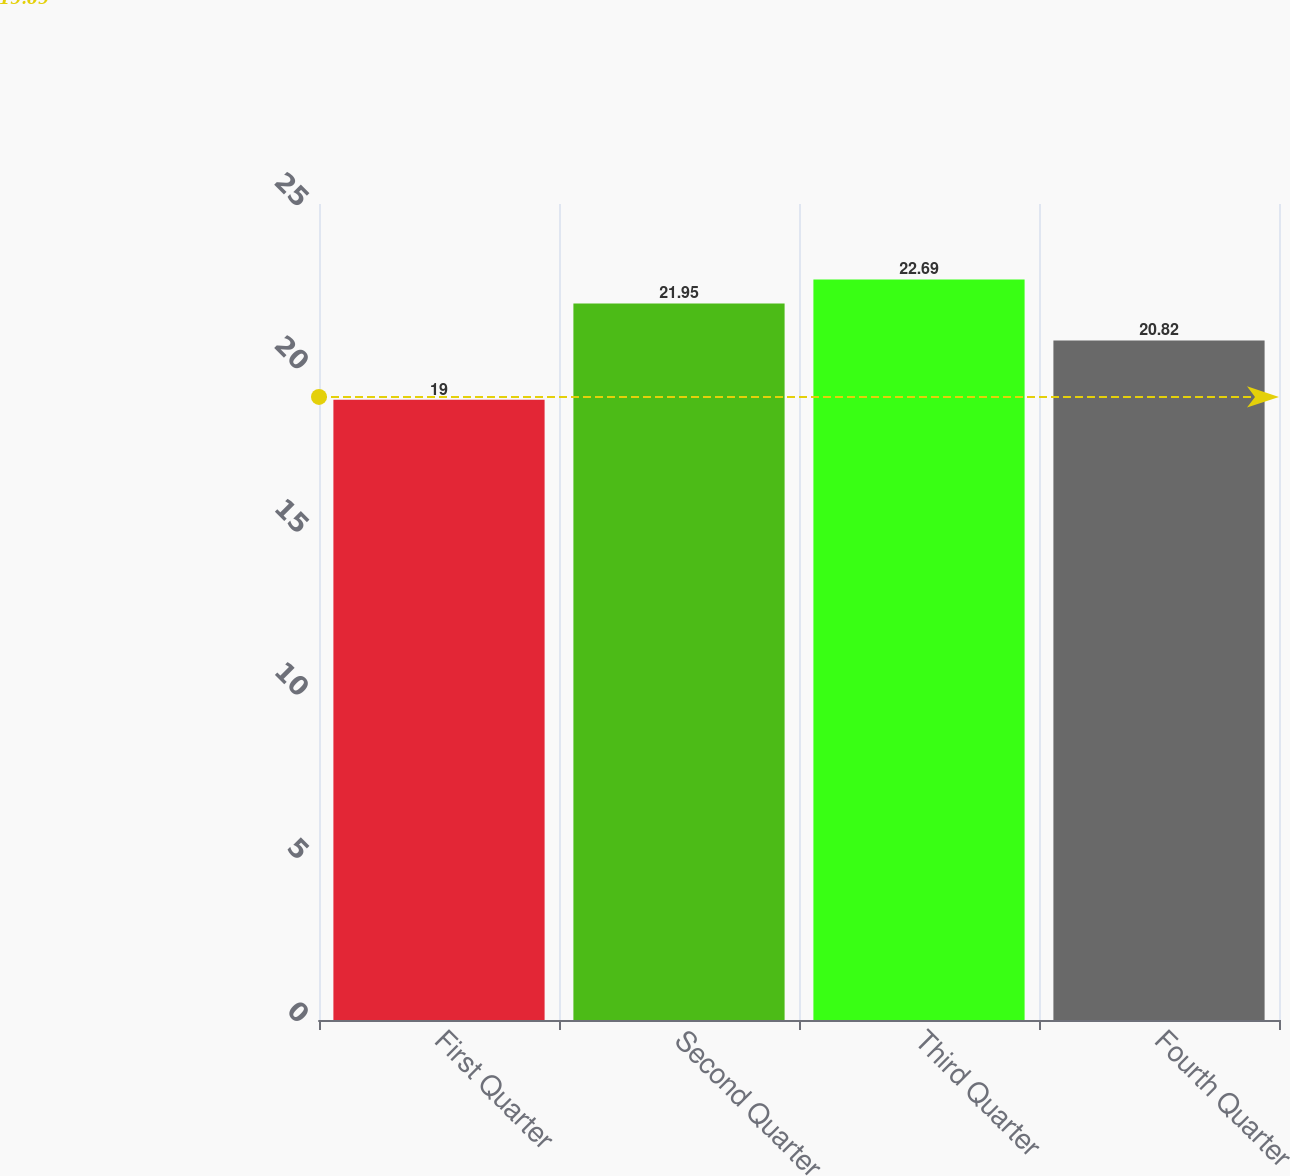<chart> <loc_0><loc_0><loc_500><loc_500><bar_chart><fcel>First Quarter<fcel>Second Quarter<fcel>Third Quarter<fcel>Fourth Quarter<nl><fcel>19<fcel>21.95<fcel>22.69<fcel>20.82<nl></chart> 